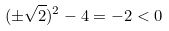<formula> <loc_0><loc_0><loc_500><loc_500>( \pm \sqrt { 2 } ) ^ { 2 } - 4 = - 2 < 0</formula> 